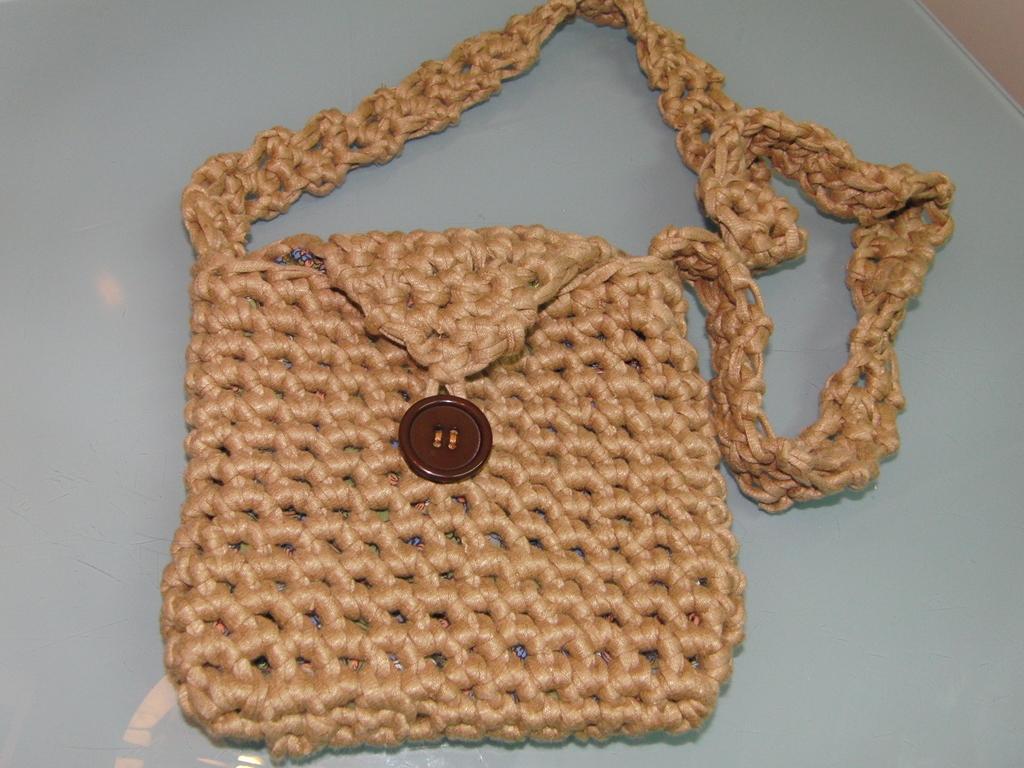Can you describe this image briefly? In this picture we can see cream color with a brown color button on it. 